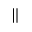Convert formula to latex. <formula><loc_0><loc_0><loc_500><loc_500>\|</formula> 